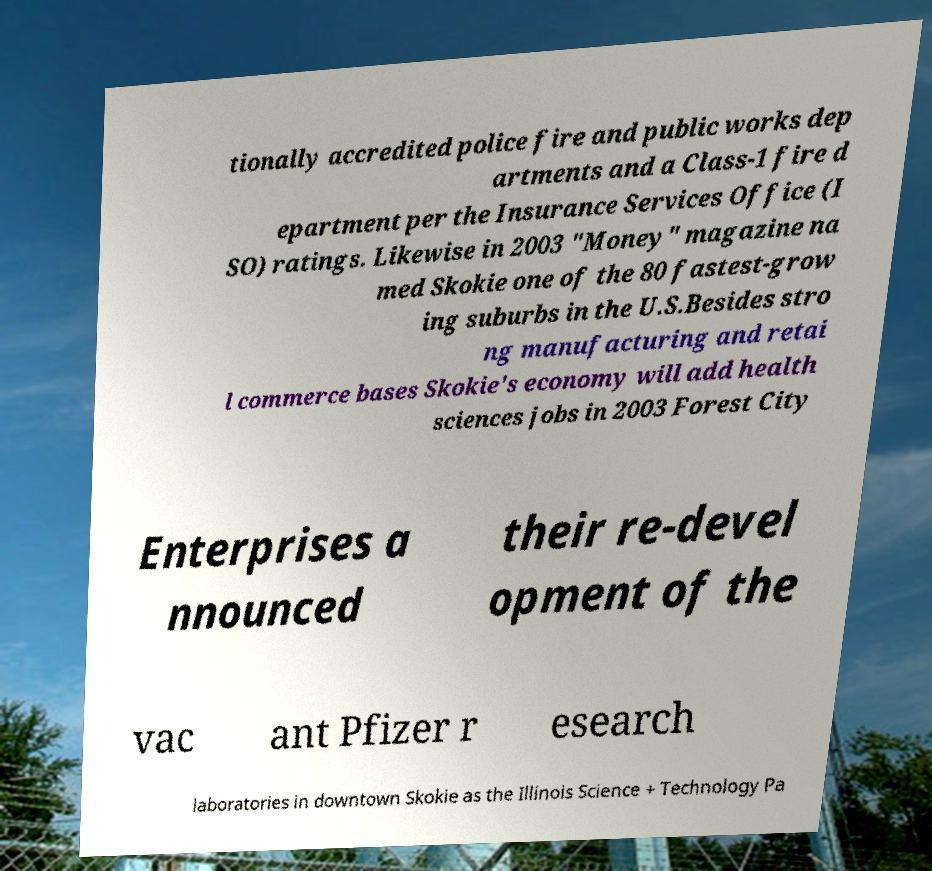Could you assist in decoding the text presented in this image and type it out clearly? tionally accredited police fire and public works dep artments and a Class-1 fire d epartment per the Insurance Services Office (I SO) ratings. Likewise in 2003 "Money" magazine na med Skokie one of the 80 fastest-grow ing suburbs in the U.S.Besides stro ng manufacturing and retai l commerce bases Skokie's economy will add health sciences jobs in 2003 Forest City Enterprises a nnounced their re-devel opment of the vac ant Pfizer r esearch laboratories in downtown Skokie as the Illinois Science + Technology Pa 